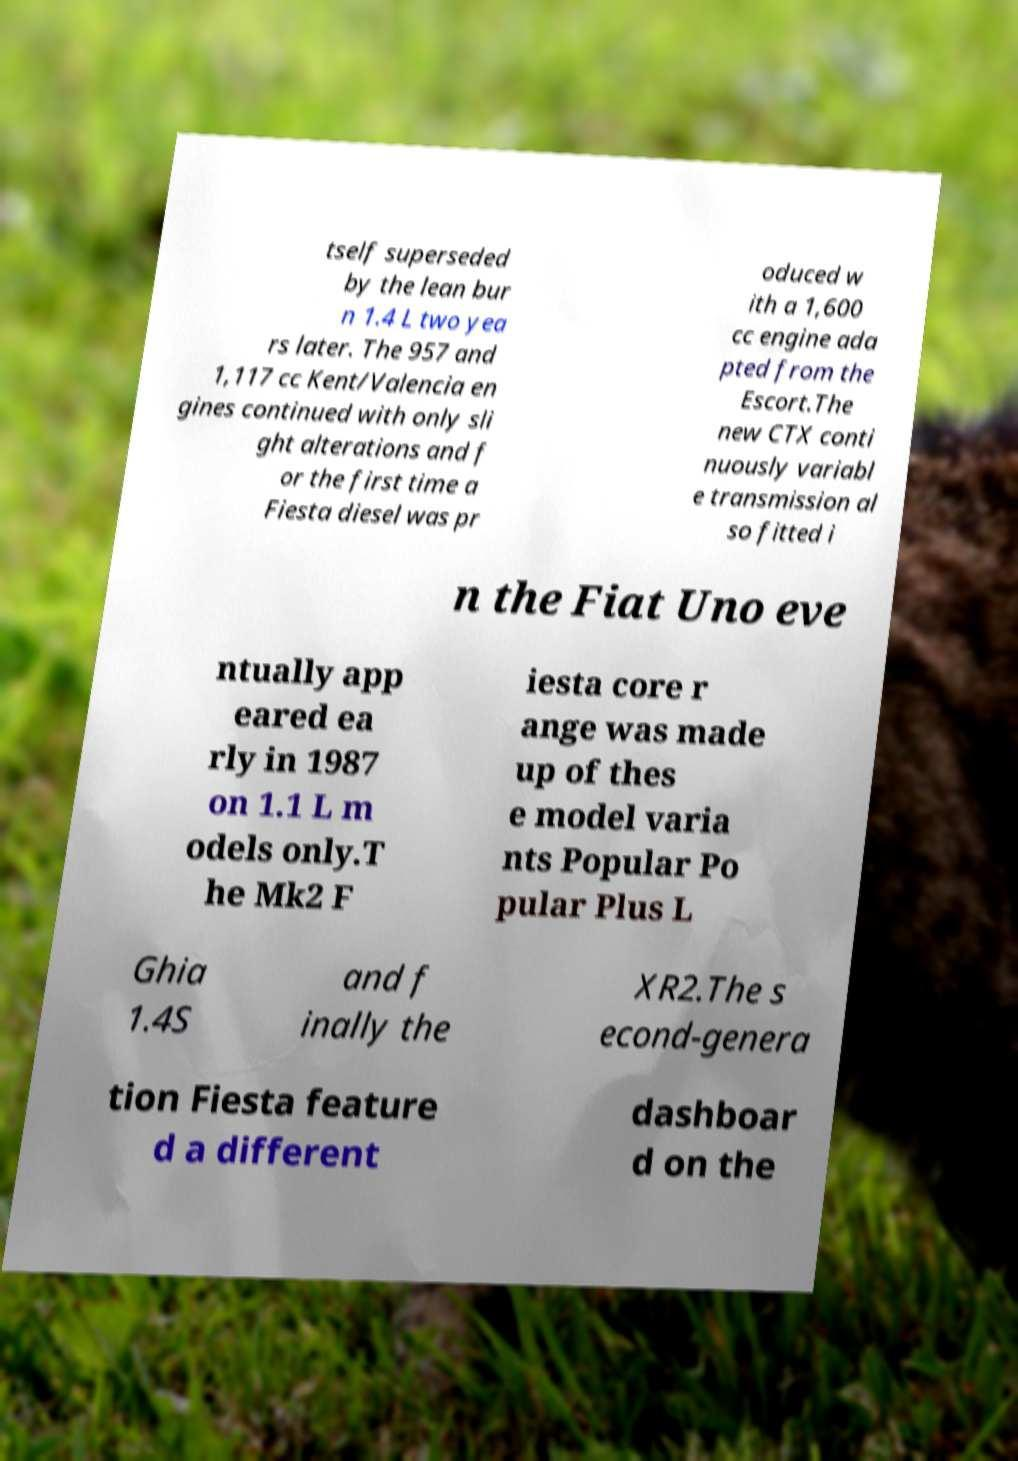Please identify and transcribe the text found in this image. tself superseded by the lean bur n 1.4 L two yea rs later. The 957 and 1,117 cc Kent/Valencia en gines continued with only sli ght alterations and f or the first time a Fiesta diesel was pr oduced w ith a 1,600 cc engine ada pted from the Escort.The new CTX conti nuously variabl e transmission al so fitted i n the Fiat Uno eve ntually app eared ea rly in 1987 on 1.1 L m odels only.T he Mk2 F iesta core r ange was made up of thes e model varia nts Popular Po pular Plus L Ghia 1.4S and f inally the XR2.The s econd-genera tion Fiesta feature d a different dashboar d on the 